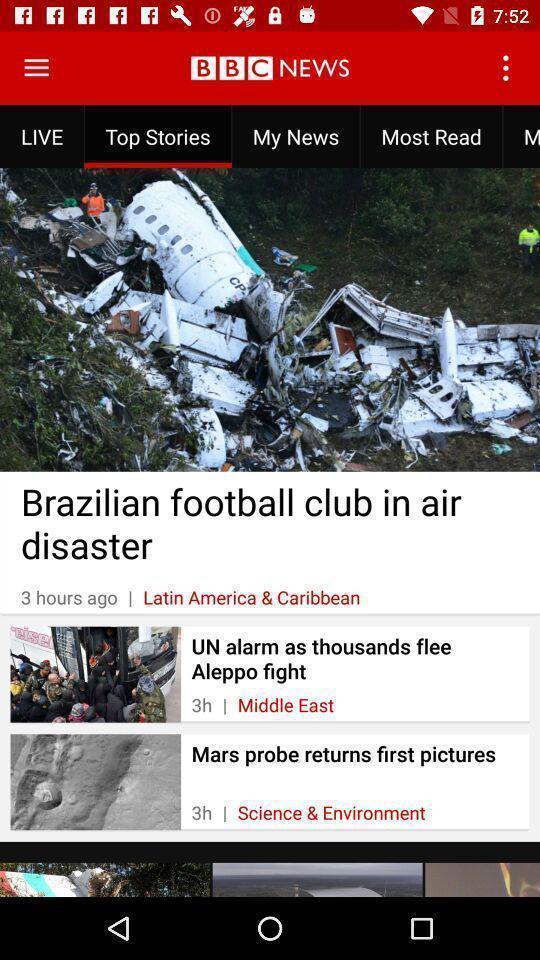What details can you identify in this image? Top stories in the news application. 